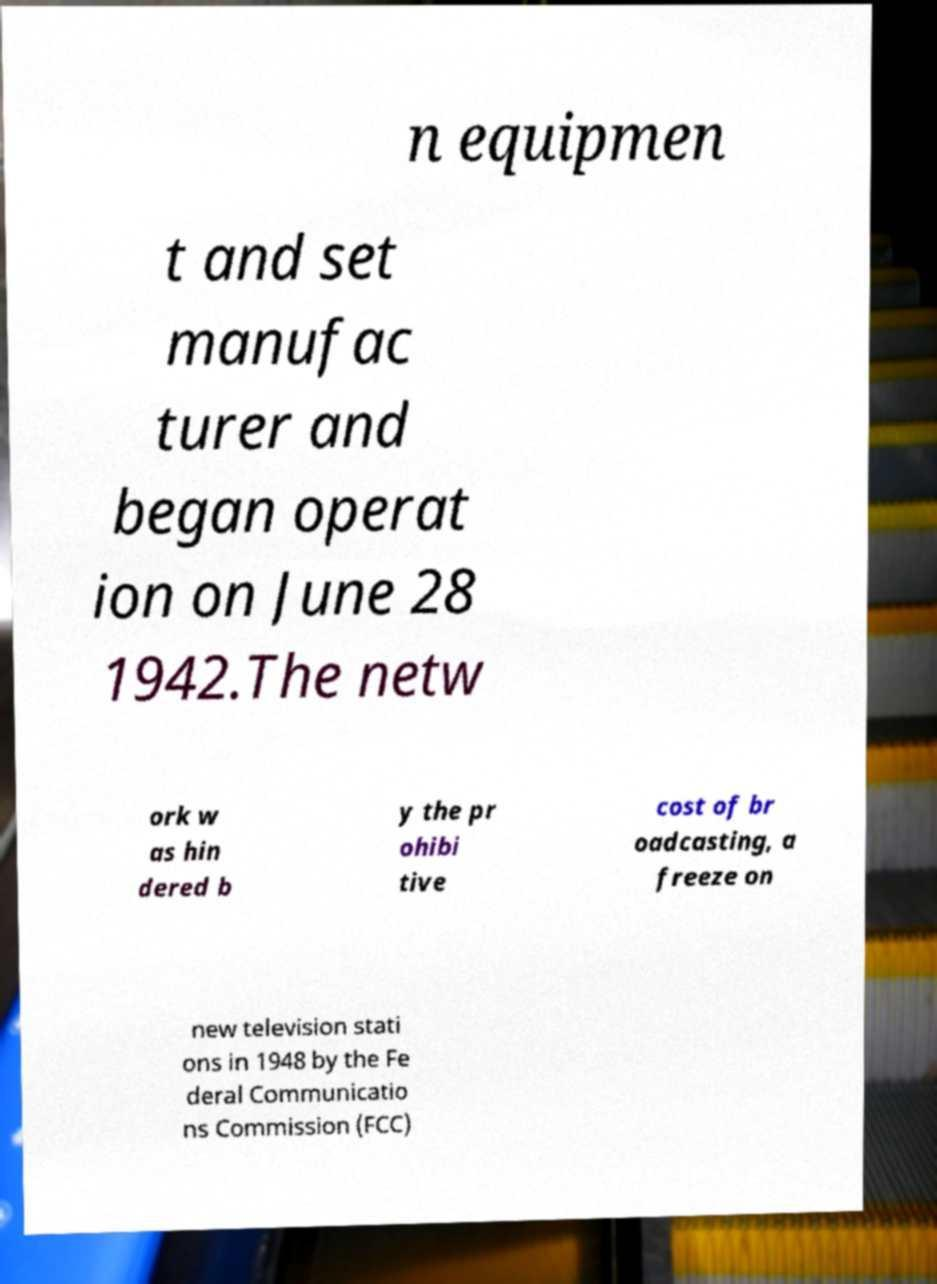What messages or text are displayed in this image? I need them in a readable, typed format. n equipmen t and set manufac turer and began operat ion on June 28 1942.The netw ork w as hin dered b y the pr ohibi tive cost of br oadcasting, a freeze on new television stati ons in 1948 by the Fe deral Communicatio ns Commission (FCC) 